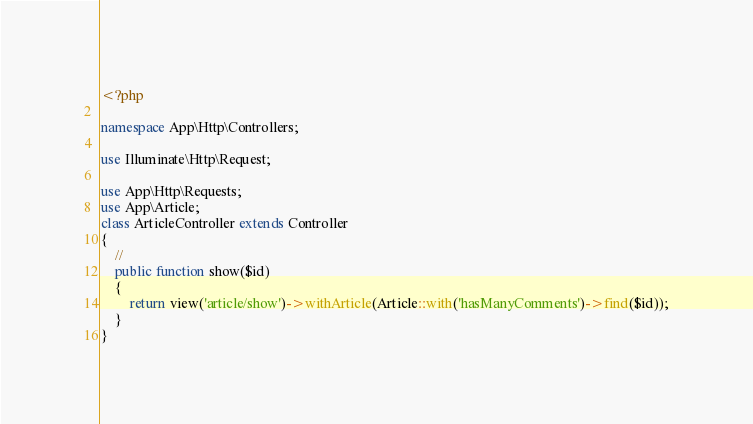<code> <loc_0><loc_0><loc_500><loc_500><_PHP_><?php

namespace App\Http\Controllers;

use Illuminate\Http\Request;

use App\Http\Requests;
use App\Article;
class ArticleController extends Controller
{
    //
    public function show($id)
    {
        return view('article/show')->withArticle(Article::with('hasManyComments')->find($id));
    }
}
</code> 